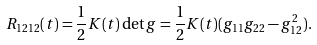<formula> <loc_0><loc_0><loc_500><loc_500>R _ { 1 2 1 2 } ( t ) = \frac { 1 } { 2 } K ( t ) \det g = \frac { 1 } { 2 } K ( t ) ( g _ { 1 1 } g _ { 2 2 } - g _ { 1 2 } ^ { 2 } ) .</formula> 